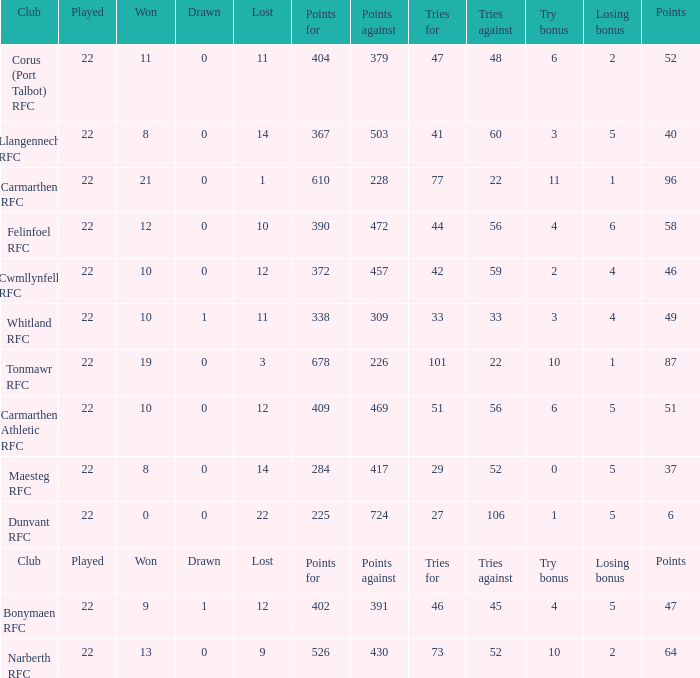Name the try bonus of points against at 430 10.0. 